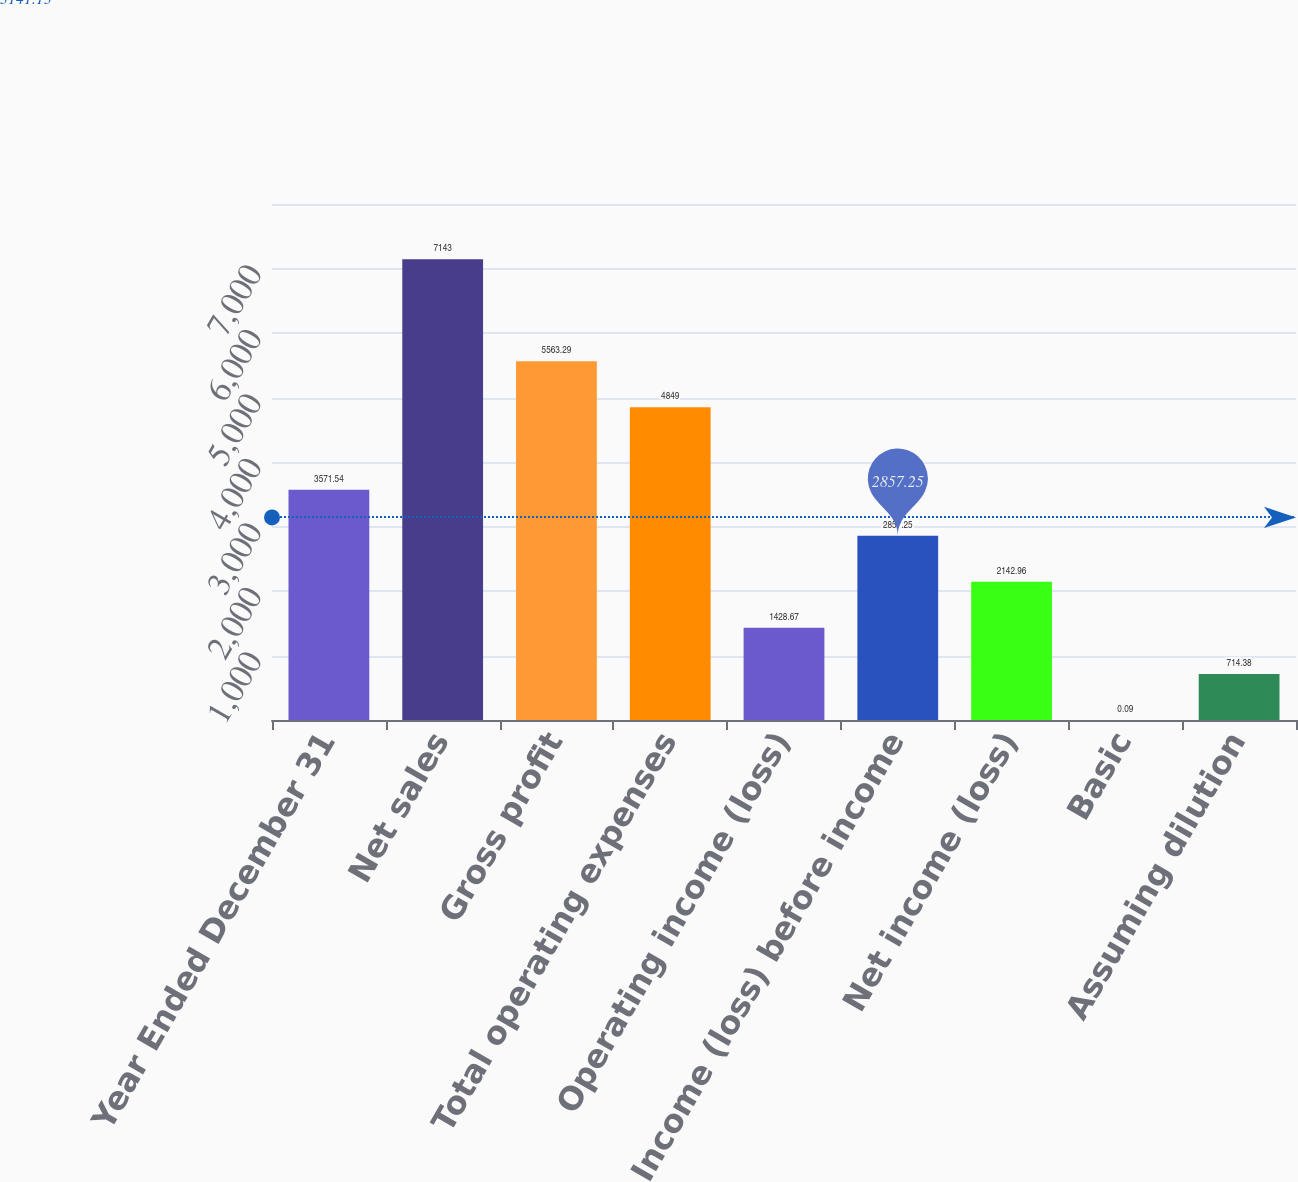<chart> <loc_0><loc_0><loc_500><loc_500><bar_chart><fcel>Year Ended December 31<fcel>Net sales<fcel>Gross profit<fcel>Total operating expenses<fcel>Operating income (loss)<fcel>Income (loss) before income<fcel>Net income (loss)<fcel>Basic<fcel>Assuming dilution<nl><fcel>3571.54<fcel>7143<fcel>5563.29<fcel>4849<fcel>1428.67<fcel>2857.25<fcel>2142.96<fcel>0.09<fcel>714.38<nl></chart> 